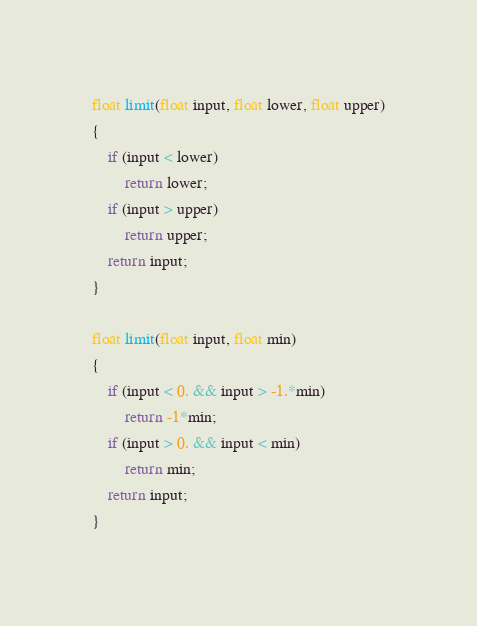<code> <loc_0><loc_0><loc_500><loc_500><_C++_>float limit(float input, float lower, float upper)
{
	if (input < lower) 
		return lower;
	if (input > upper)
		return upper;
	return input;
}

float limit(float input, float min)
{
	if (input < 0. && input > -1.*min)
		return -1*min;
	if (input > 0. && input < min)
		return min;
	return input;
}
</code> 